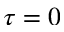<formula> <loc_0><loc_0><loc_500><loc_500>\tau = 0</formula> 